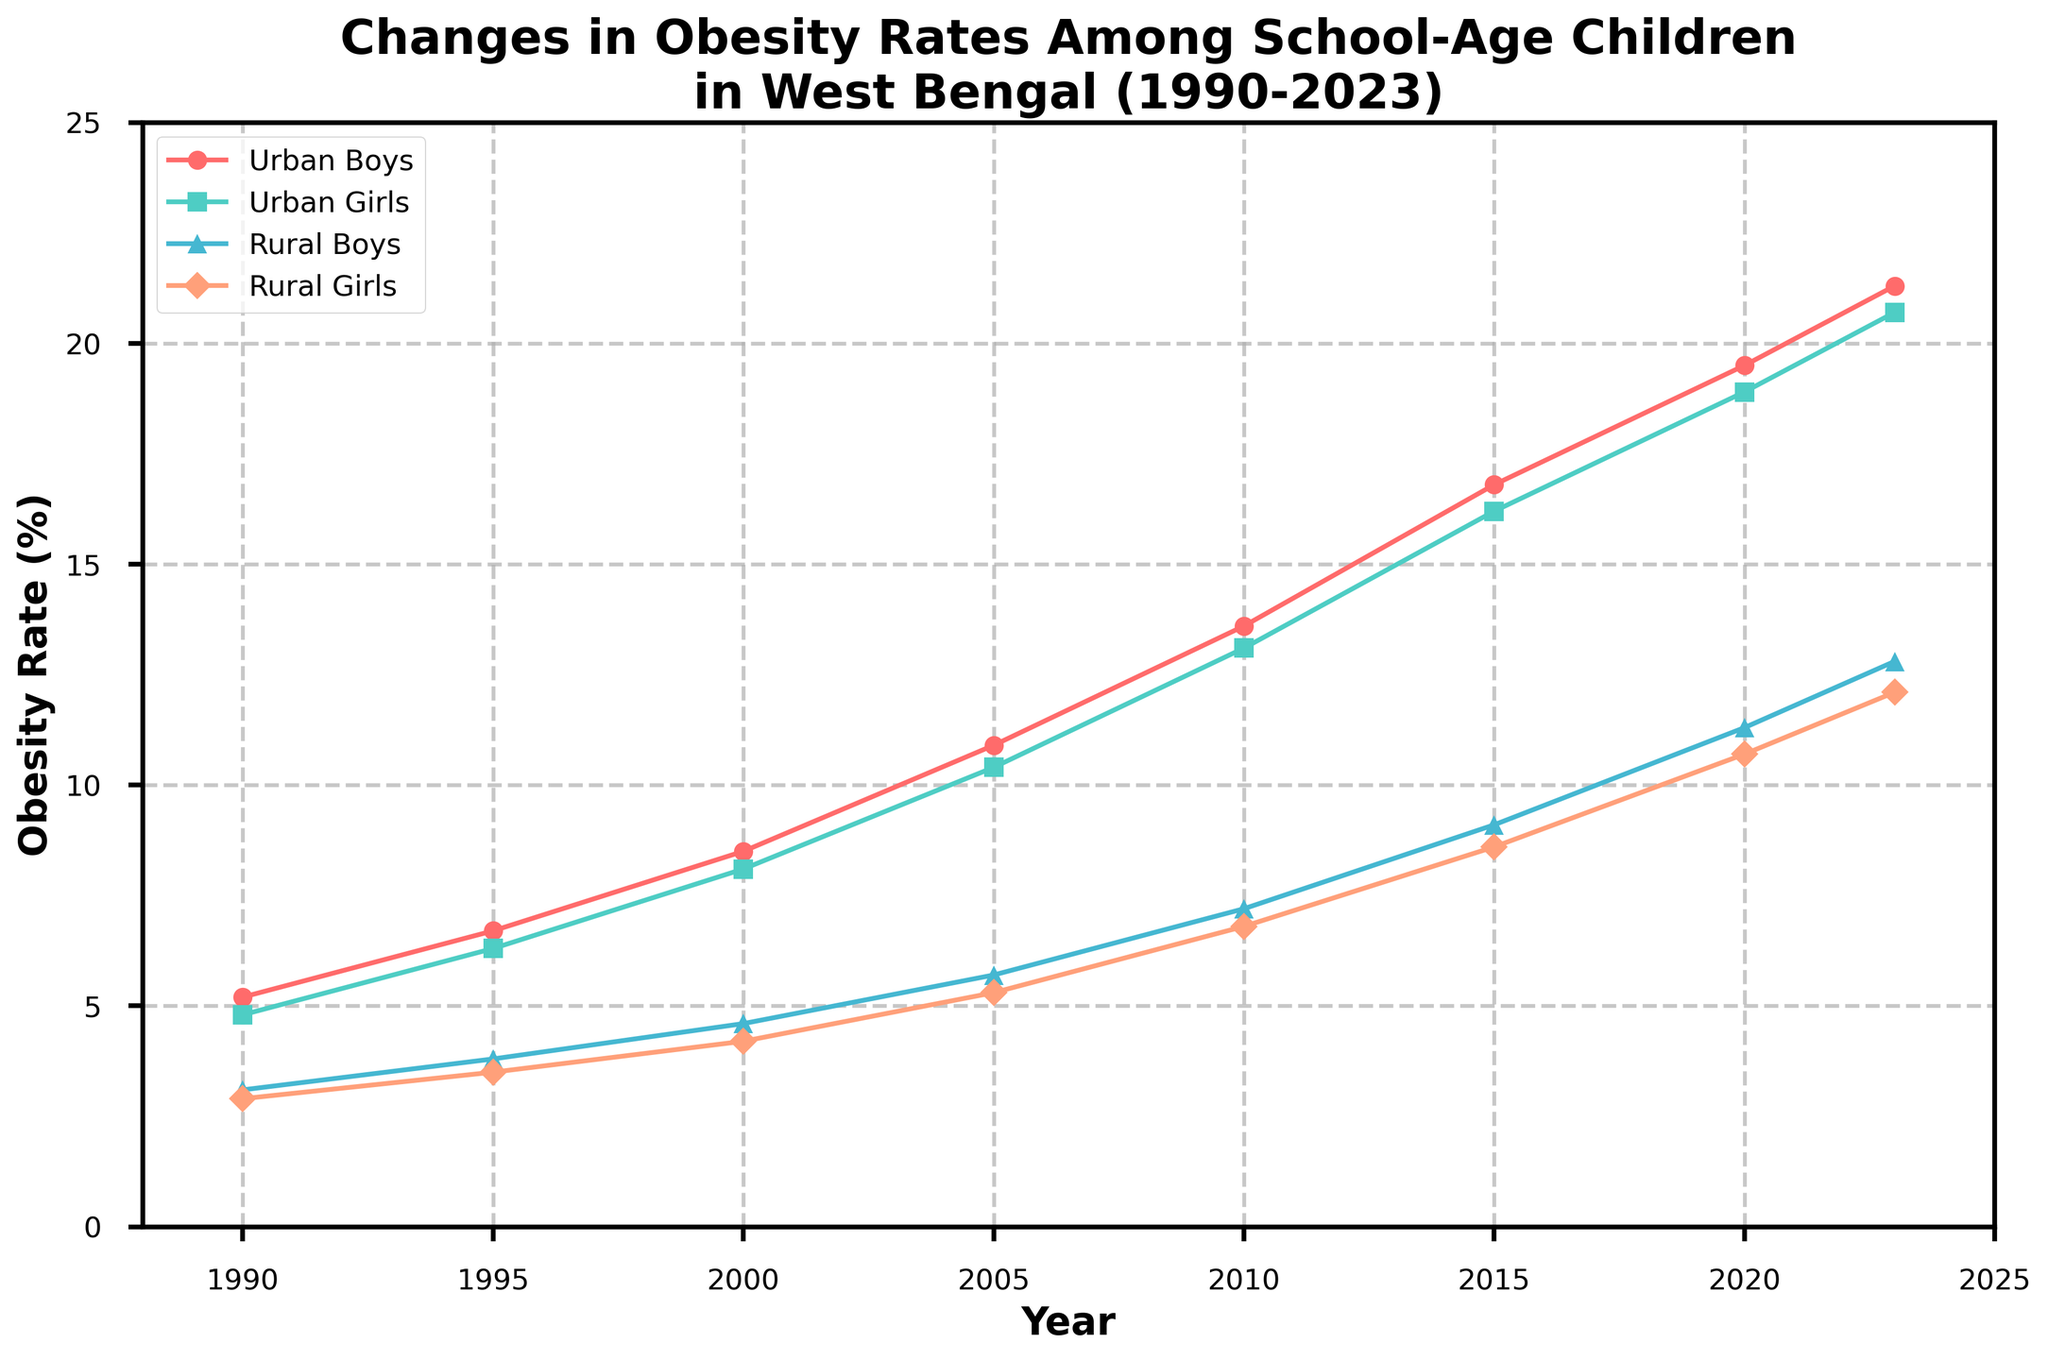What trend do we observe in the obesity rates of Urban Boys from 1990 to 2023? To determine the trend for Urban Boys' obesity rates, identify the values for each year: 5.2% (1990), 6.7% (1995), 8.5% (2000), 10.9% (2005), 13.6% (2010), 16.8% (2015), 19.5% (2020), and 21.3% (2023). Observing these data points, we see a continuous increase in the obesity rates.
Answer: Increasing trend How much did the obesity rate for Rural Girls increase between 1990 and 2023? Subtract the obesity rate in 1990 from the rate in 2023: 12.1% (2023) - 2.9% (1990) = 9.2%. So the increase is 9.2%.
Answer: 9.2% Which group experienced the highest obesity rate in 2023? Compare the obesity rates for Urban Boys, Urban Girls, Rural Boys, and Rural Girls in 2023. The values are Urban Boys 21.3%, Urban Girls 20.7%, Rural Boys 12.8%, and Rural Girls 12.1%. The highest rate is for Urban Boys at 21.3%.
Answer: Urban Boys What is the overall trend for the obesity rates of rural children from 1990 to 2023? Observe the rates for Rural Boys: 3.1% (1990), 3.8% (1995), 4.6% (2000), 5.7% (2005), 7.2% (2010), 9.1% (2015), 11.3% (2020), and 12.8% (2023). For Rural Girls: 2.9% (1990), 3.5% (1995), 4.2% (2000), 5.3% (2005), 6.8% (2010), 8.6% (2015), 10.7% (2020), and 12.1% (2023). Both groups show a continuous increase.
Answer: Increasing trend In which year did Urban Boys have an obesity rate of approximately 17%? From the line representing Urban Boys, locate the point closest to 17%. This occurs in the year 2015 when the rate is 16.8%.
Answer: 2015 Compare the rate of increase in obesity between Urban Girls and Rural Boys from 1990 to 2023. Which group had a higher rate of increase? Calculate the increase for each group. Urban Girls: 20.7% (2023) - 4.8% (1990) = 15.9%. Rural Boys: 12.8% (2023) - 3.1% (1990) = 9.7%. Urban Girls had a higher rate of increase (15.9% vs 9.7%).
Answer: Urban Girls How does the obesity rate of Rural Boys in 2020 compare to that of Urban Girls in 2000? Locate the values from the chart: Rural Boys in 2020 is 11.3%, and Urban Girls in 2000 is 8.1%. Rural Boys in 2020 have a higher obesity rate (11.3% vs 8.1%).
Answer: Rural Boys in 2020 What is the difference in obesity rates between Urban Boys and Urban Girls in 2023? Subtract the obesity rate of Urban Girls from Urban Boys in 2023: 21.3% (Urban Boys) - 20.7% (Urban Girls) = 0.6%.
Answer: 0.6% What was the rate of increase in obesity for Urban Boys between 1990 and 2020? Calculate the increase between the two years for Urban Boys: 19.5% (2020) - 5.2% (1990) = 14.3%.
Answer: 14.3% Which rural group showed a higher obesity rate in 2010 and by how much? Compare the rates for Rural Boys and Rural Girls in 2010 from the chart: Rural Boys (7.2%) and Rural Girls (6.8%). The difference is 7.2% - 6.8% = 0.4%. Rural Boys have a higher rate.
Answer: Rural Boys by 0.4% 